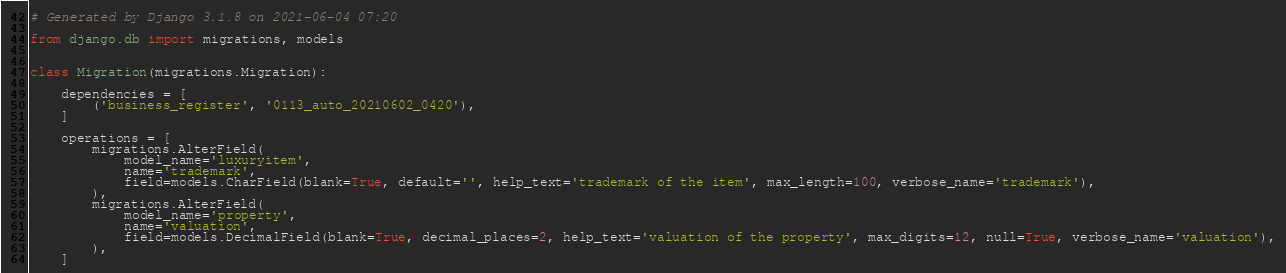<code> <loc_0><loc_0><loc_500><loc_500><_Python_># Generated by Django 3.1.8 on 2021-06-04 07:20

from django.db import migrations, models


class Migration(migrations.Migration):

    dependencies = [
        ('business_register', '0113_auto_20210602_0420'),
    ]

    operations = [
        migrations.AlterField(
            model_name='luxuryitem',
            name='trademark',
            field=models.CharField(blank=True, default='', help_text='trademark of the item', max_length=100, verbose_name='trademark'),
        ),
        migrations.AlterField(
            model_name='property',
            name='valuation',
            field=models.DecimalField(blank=True, decimal_places=2, help_text='valuation of the property', max_digits=12, null=True, verbose_name='valuation'),
        ),
    ]
</code> 